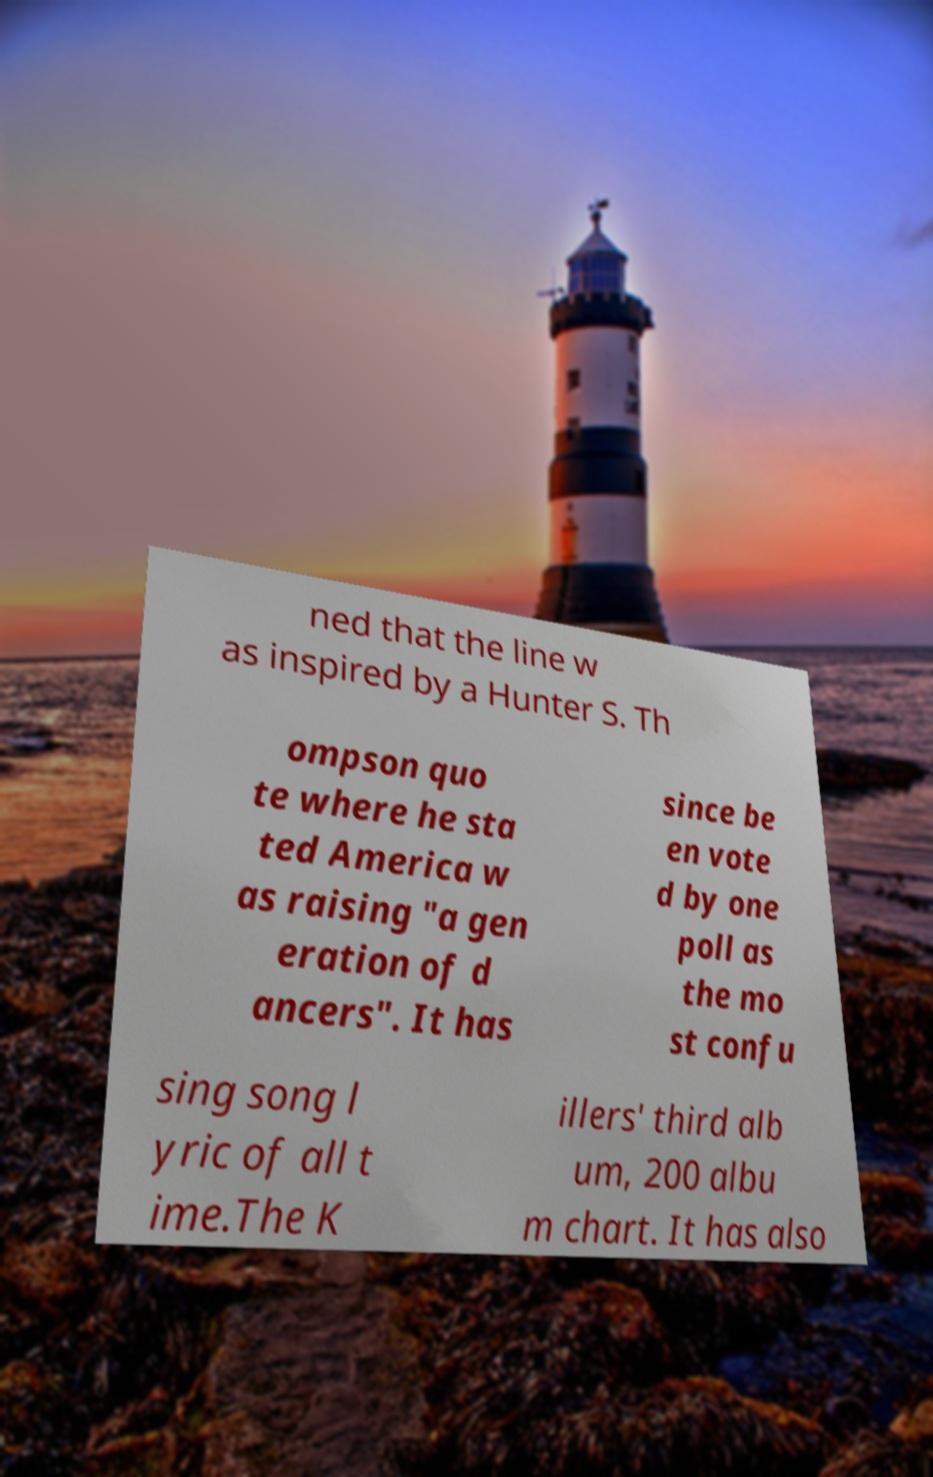For documentation purposes, I need the text within this image transcribed. Could you provide that? ned that the line w as inspired by a Hunter S. Th ompson quo te where he sta ted America w as raising "a gen eration of d ancers". It has since be en vote d by one poll as the mo st confu sing song l yric of all t ime.The K illers' third alb um, 200 albu m chart. It has also 